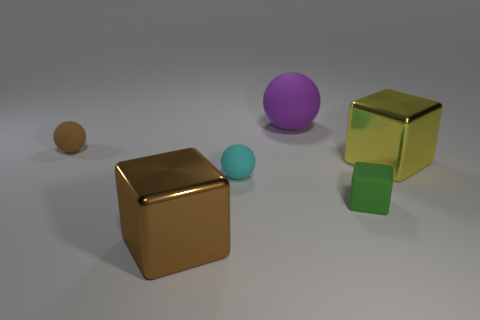Subtract all small matte spheres. How many spheres are left? 1 Add 1 blue shiny spheres. How many objects exist? 7 Subtract all brown cubes. How many cubes are left? 2 Subtract 1 cyan spheres. How many objects are left? 5 Subtract 2 spheres. How many spheres are left? 1 Subtract all gray spheres. Subtract all yellow blocks. How many spheres are left? 3 Subtract all red balls. How many brown blocks are left? 1 Subtract all cyan objects. Subtract all brown spheres. How many objects are left? 4 Add 5 small brown spheres. How many small brown spheres are left? 6 Add 5 tiny yellow cubes. How many tiny yellow cubes exist? 5 